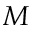<formula> <loc_0><loc_0><loc_500><loc_500>M</formula> 